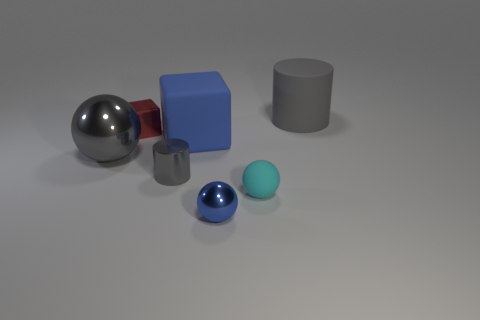Subtract all red blocks. How many blocks are left? 1 Subtract all small cyan rubber balls. How many balls are left? 2 Add 1 blue metallic things. How many objects exist? 8 Subtract all cylinders. How many objects are left? 5 Subtract all yellow cylinders. Subtract all cyan spheres. How many cylinders are left? 2 Subtract all green cylinders. How many gray blocks are left? 0 Subtract all blue balls. Subtract all brown matte cylinders. How many objects are left? 6 Add 6 cylinders. How many cylinders are left? 8 Add 1 metal cylinders. How many metal cylinders exist? 2 Subtract 0 green cylinders. How many objects are left? 7 